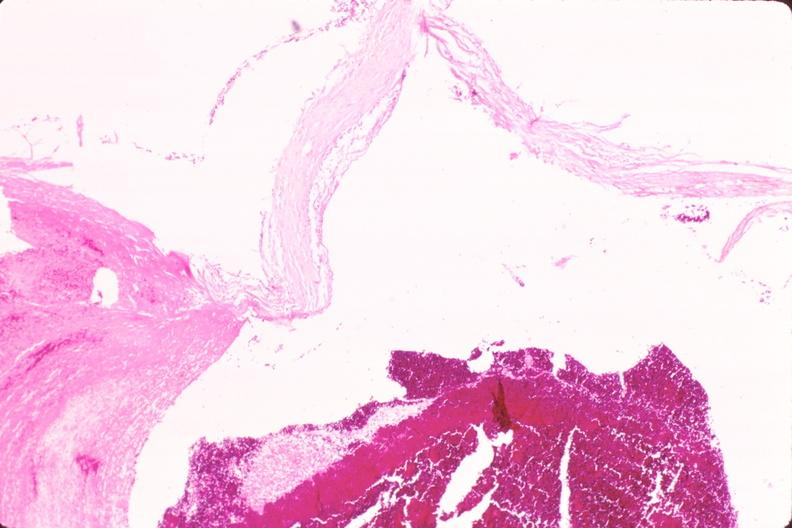does granulomata slide show ruptured saccular aneurysm right middle cerebral artery?
Answer the question using a single word or phrase. No 